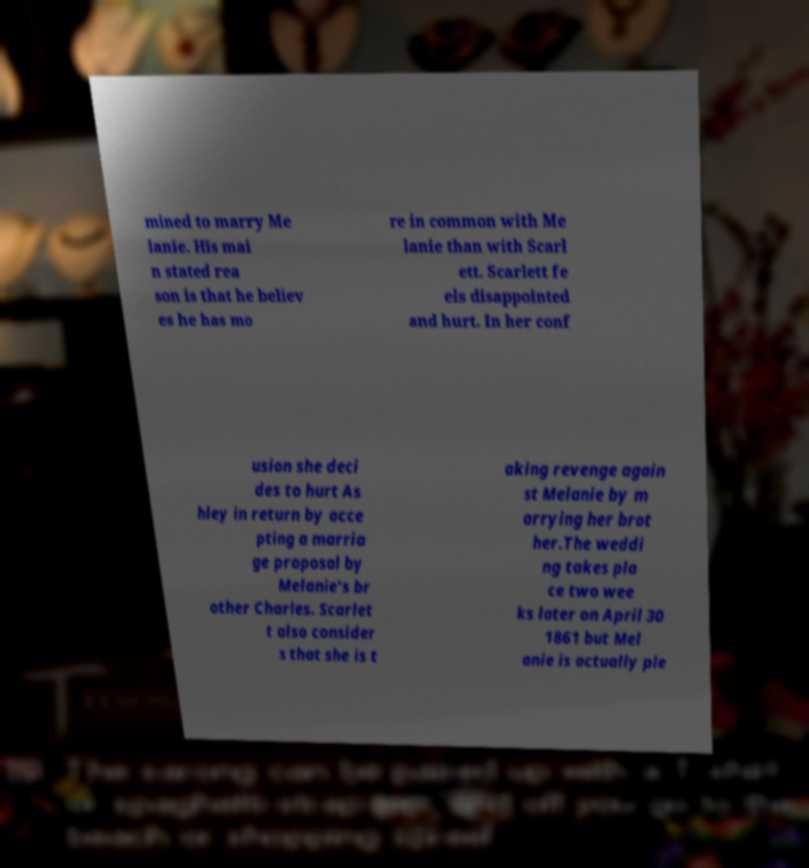Could you assist in decoding the text presented in this image and type it out clearly? mined to marry Me lanie. His mai n stated rea son is that he believ es he has mo re in common with Me lanie than with Scarl ett. Scarlett fe els disappointed and hurt. In her conf usion she deci des to hurt As hley in return by acce pting a marria ge proposal by Melanie's br other Charles. Scarlet t also consider s that she is t aking revenge again st Melanie by m arrying her brot her.The weddi ng takes pla ce two wee ks later on April 30 1861 but Mel anie is actually ple 